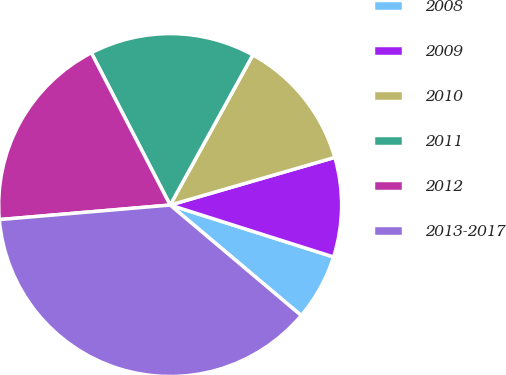Convert chart. <chart><loc_0><loc_0><loc_500><loc_500><pie_chart><fcel>2008<fcel>2009<fcel>2010<fcel>2011<fcel>2012<fcel>2013-2017<nl><fcel>6.25%<fcel>9.38%<fcel>12.5%<fcel>15.62%<fcel>18.75%<fcel>37.5%<nl></chart> 